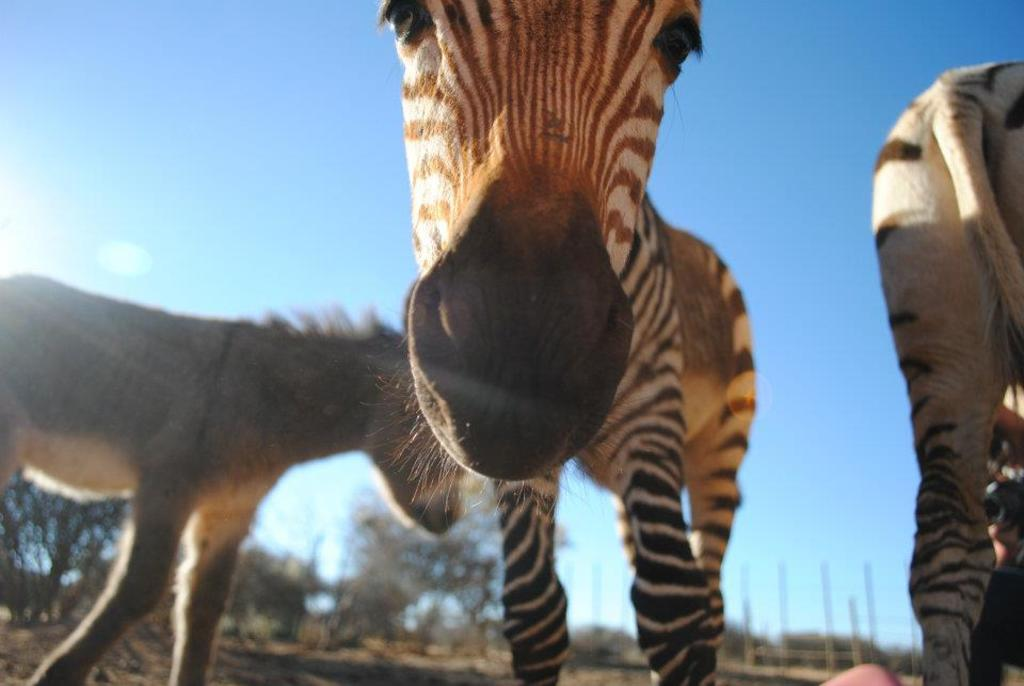What types of living organisms can be seen in the image? There are animals in the image. What can be seen in the background of the image? There are trees and poles in the background of the image. What is visible at the top of the image? The sky is visible at the top of the image. What type of book can be seen on the crib in the image? There is no book or crib present in the image. 